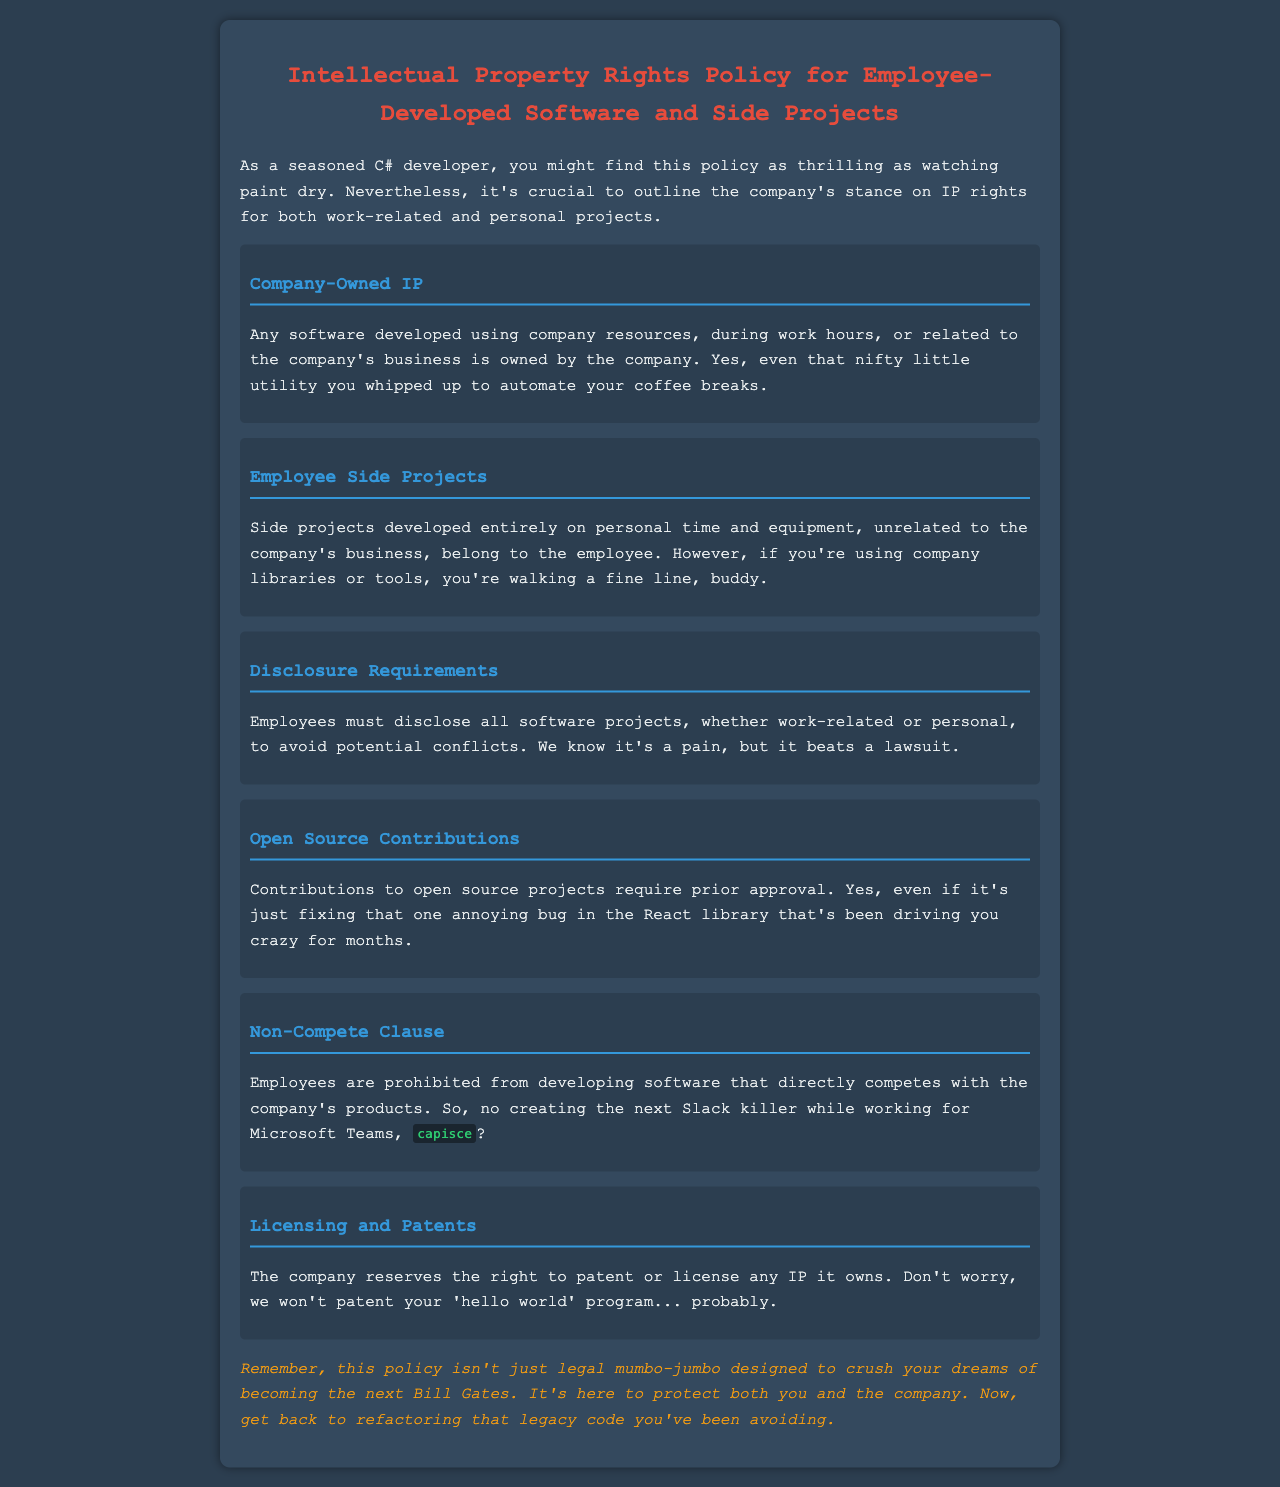what happens to software developed during work hours? Software developed using company resources, during work hours, or related to the company's business is owned by the company.
Answer: owned by the company who must disclose software projects? Employees must disclose all software projects to avoid potential conflicts.
Answer: Employees what projects require prior approval? Contributions to open source projects require prior approval.
Answer: open source projects what is prohibited by the non-compete clause? Employees are prohibited from developing software that directly competes with the company's products.
Answer: developing competing software what does the company reserve the right to patent? The company reserves the right to patent or license any IP it owns.
Answer: any IP it owns how should side projects be developed to belong to the employee? Side projects developed entirely on personal time and equipment, unrelated to the company's business, belong to the employee.
Answer: entirely on personal time and equipment 